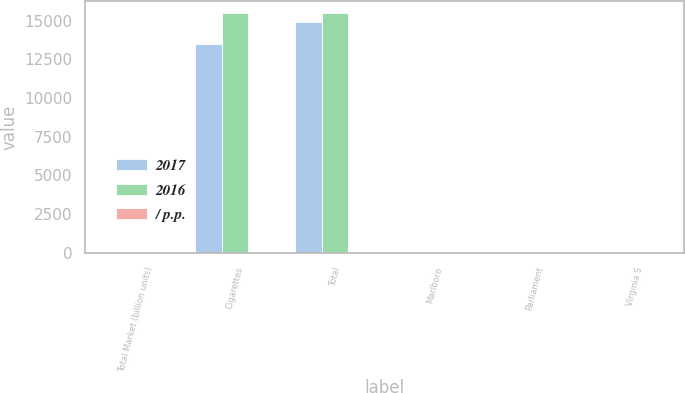<chart> <loc_0><loc_0><loc_500><loc_500><stacked_bar_chart><ecel><fcel>Total Market (billion units)<fcel>Cigarettes<fcel>Total<fcel>Marlboro<fcel>Parliament<fcel>Virginia S<nl><fcel>2017<fcel>70.6<fcel>13499<fcel>14937<fcel>8.7<fcel>8<fcel>2<nl><fcel>2016<fcel>73.6<fcel>15490<fcel>15490<fcel>9.6<fcel>7.9<fcel>3<nl><fcel>/ p.p.<fcel>4.1<fcel>12.9<fcel>3.6<fcel>0.9<fcel>0.1<fcel>1<nl></chart> 